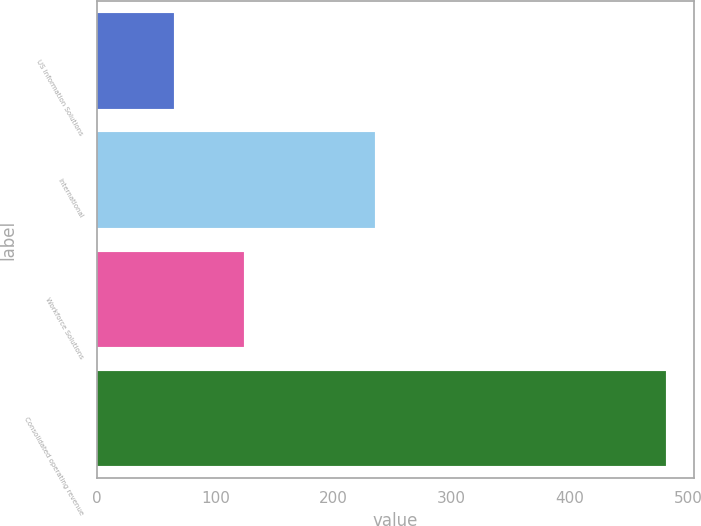<chart> <loc_0><loc_0><loc_500><loc_500><bar_chart><fcel>US Information Solutions<fcel>International<fcel>Workforce Solutions<fcel>Consolidated operating revenue<nl><fcel>65.2<fcel>235.1<fcel>124.5<fcel>481.3<nl></chart> 